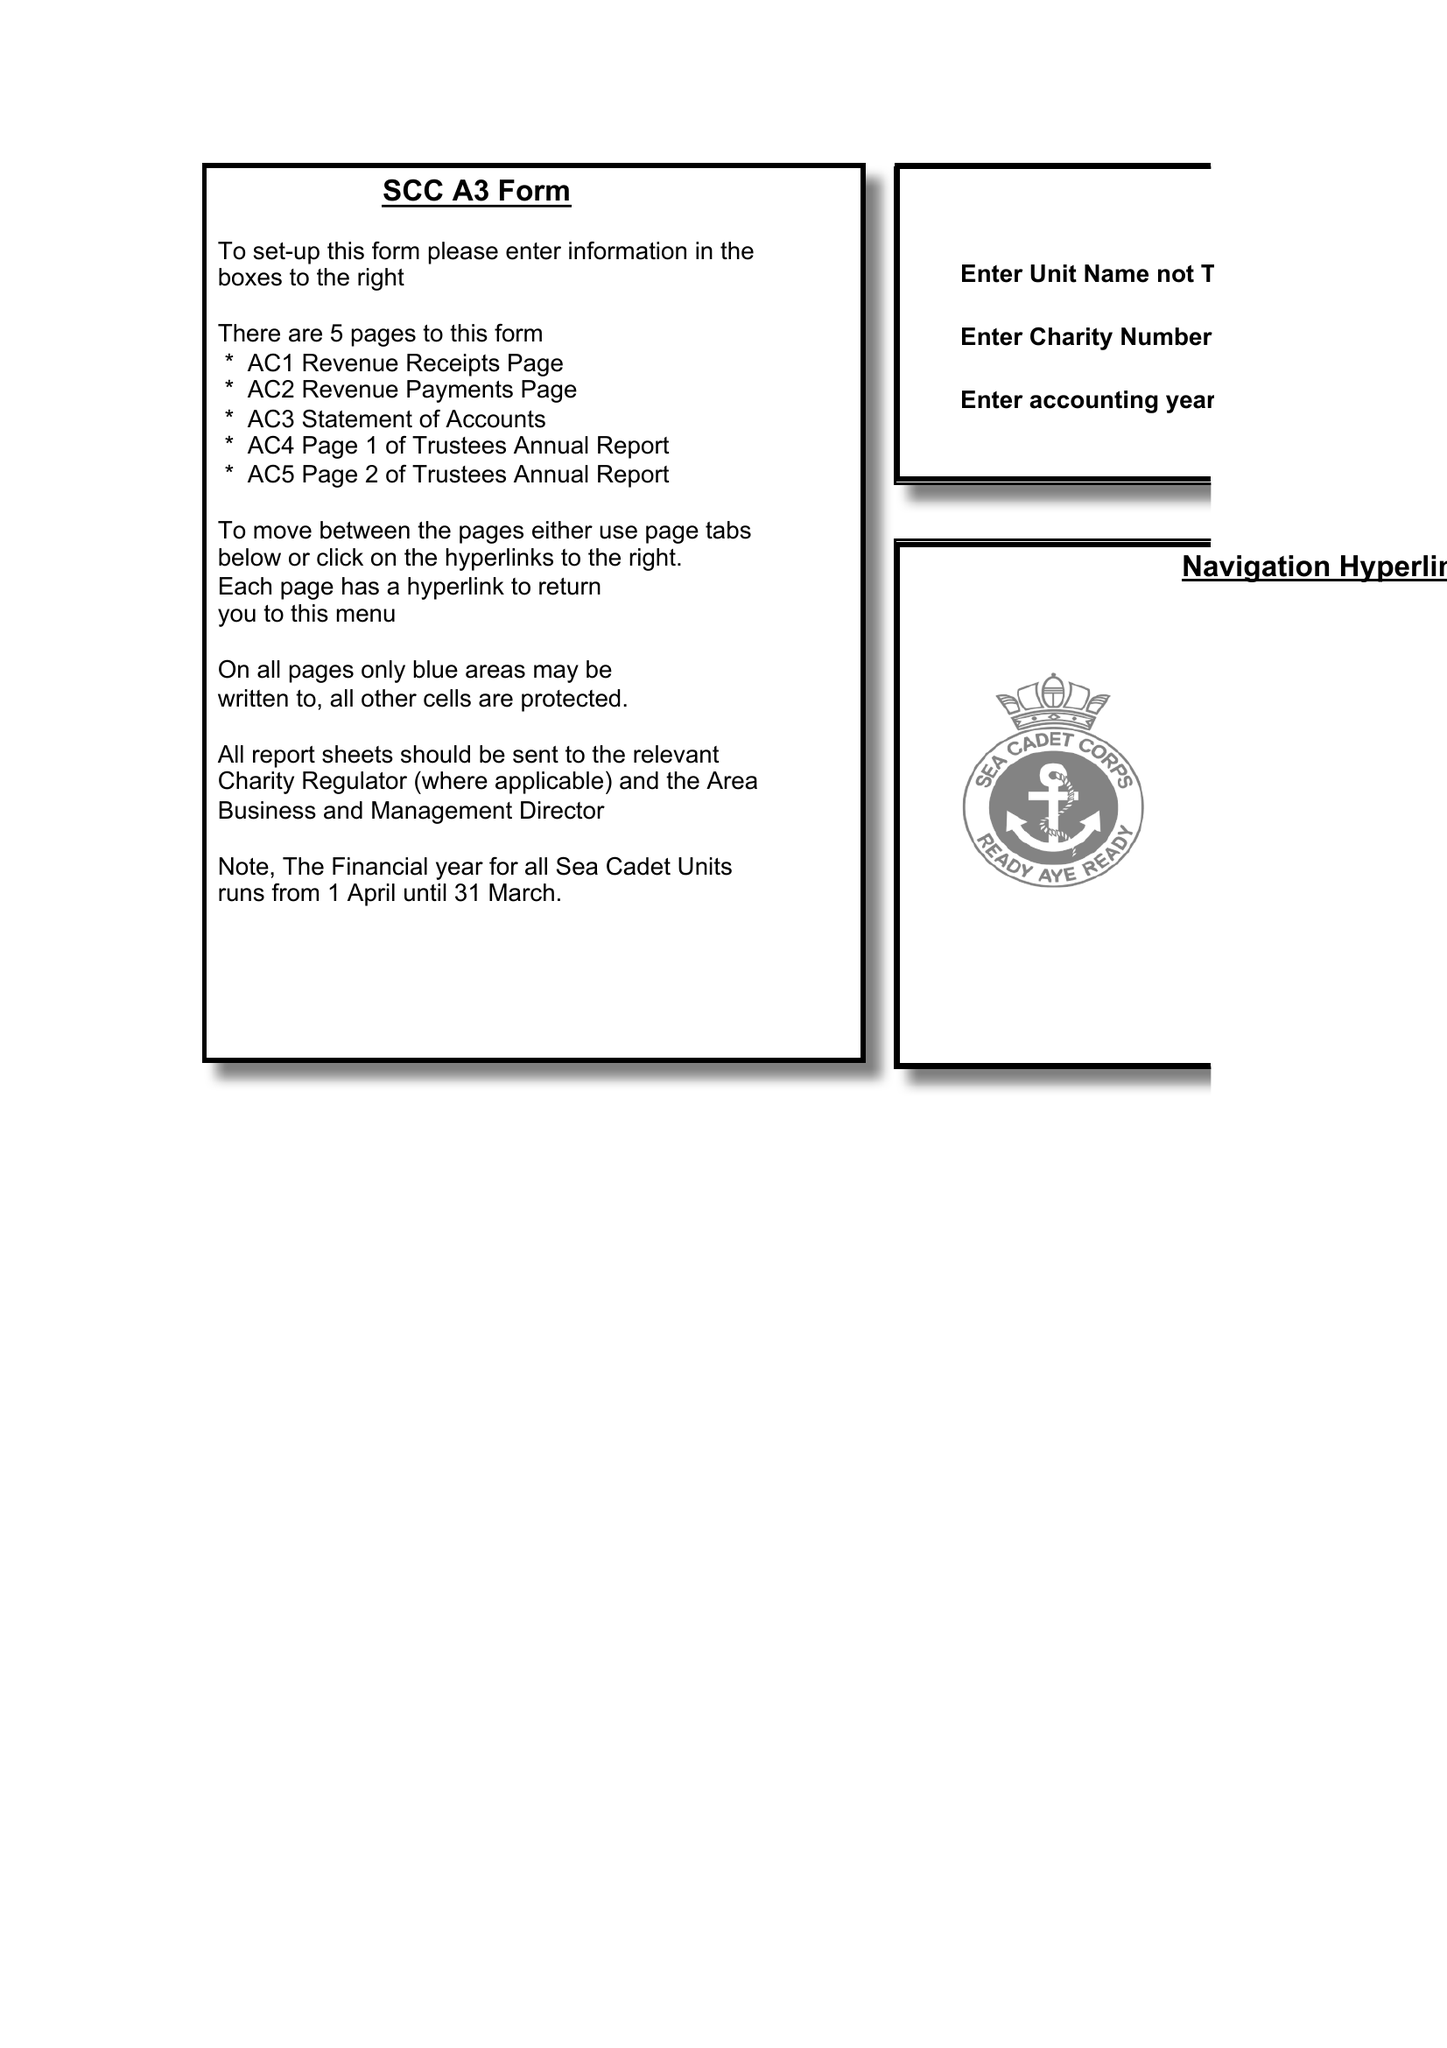What is the value for the address__street_line?
Answer the question using a single word or phrase. 16 KITTIWAKE CLOSE 